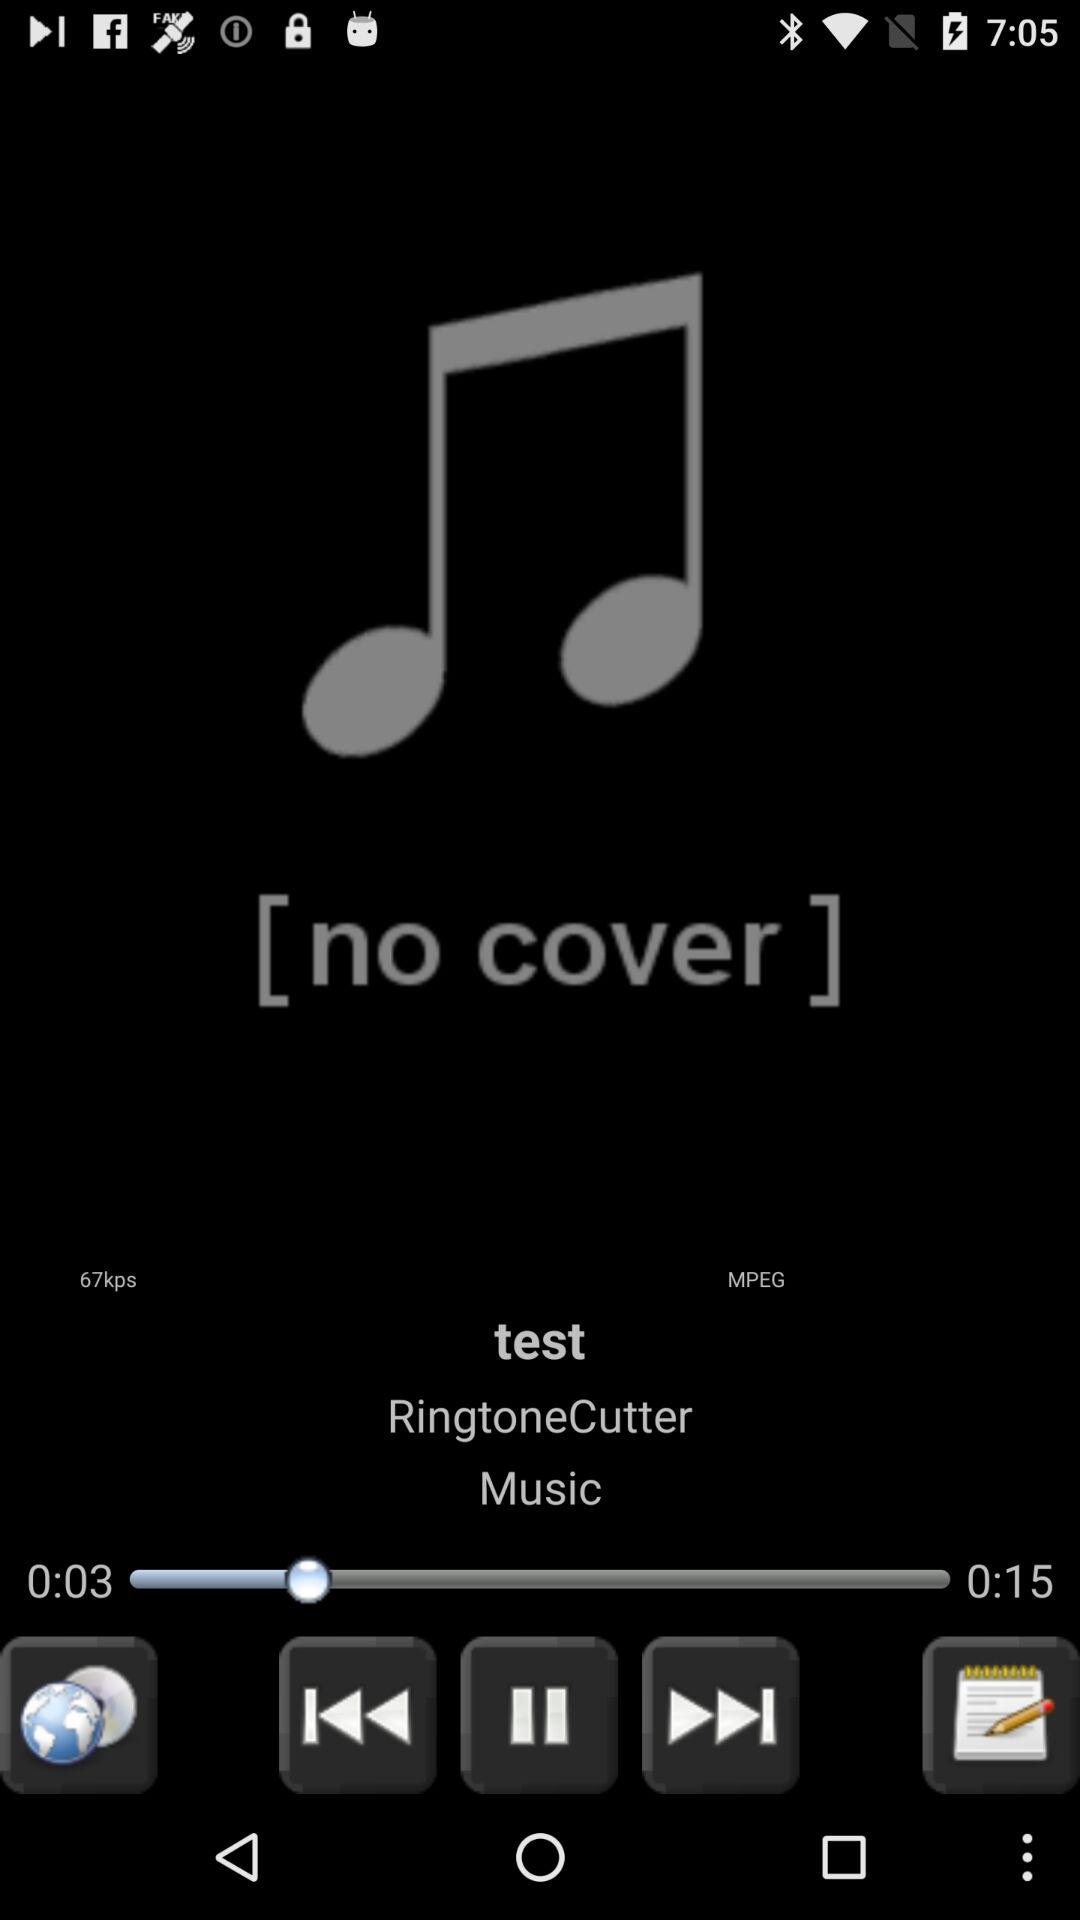What is the duration of the current song? The duration is 15 seconds. 